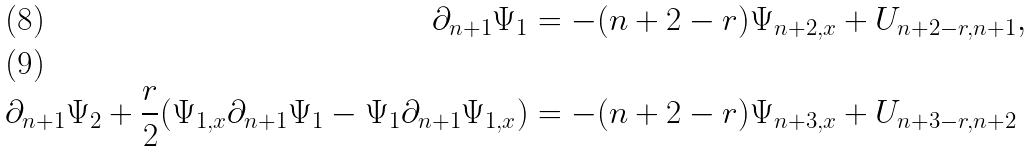<formula> <loc_0><loc_0><loc_500><loc_500>\partial _ { n + 1 } \Psi _ { 1 } & = - ( n + 2 - r ) \Psi _ { n + 2 , x } + U _ { n + 2 - r , n + 1 } , \\ \partial _ { n + 1 } \Psi _ { 2 } + \frac { r } { 2 } ( \Psi _ { 1 , x } \partial _ { n + 1 } \Psi _ { 1 } - \Psi _ { 1 } \partial _ { n + 1 } \Psi _ { 1 , x } ) & = - ( n + 2 - r ) \Psi _ { n + 3 , x } + U _ { n + 3 - r , n + 2 }</formula> 